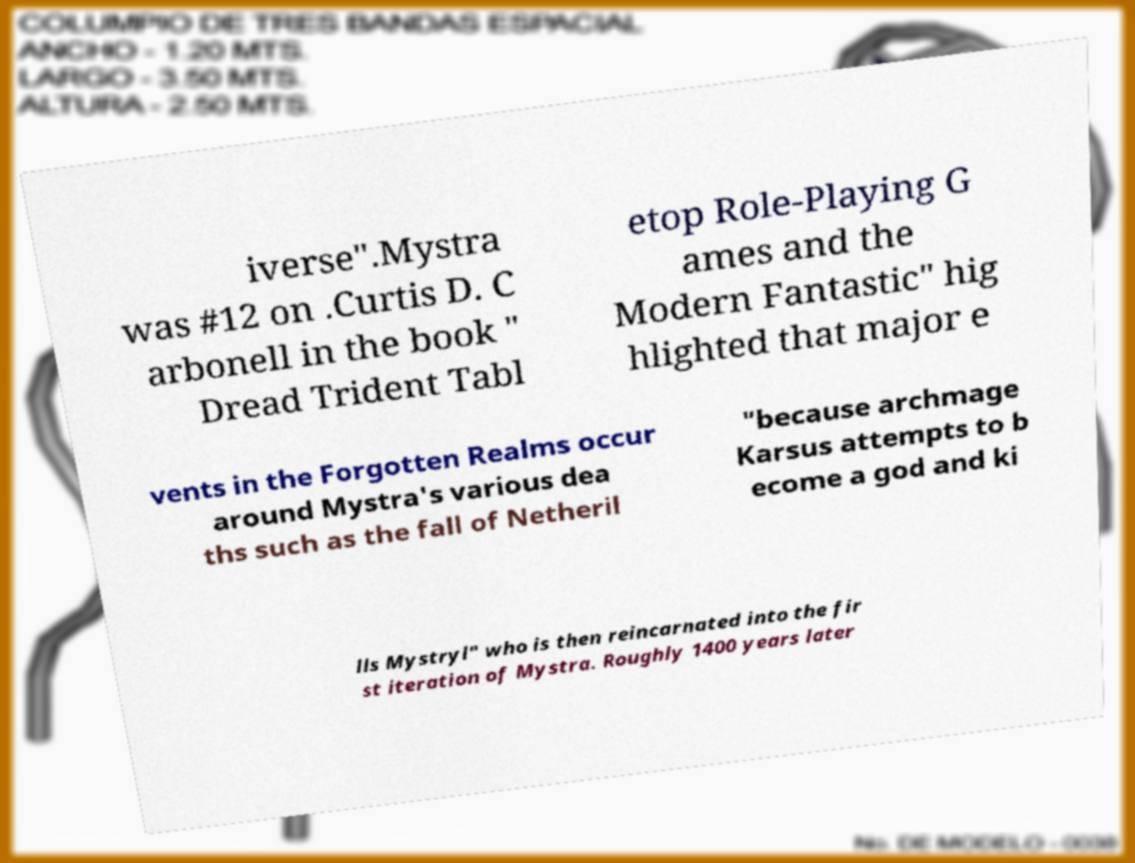Please read and relay the text visible in this image. What does it say? iverse".Mystra was #12 on .Curtis D. C arbonell in the book " Dread Trident Tabl etop Role-Playing G ames and the Modern Fantastic" hig hlighted that major e vents in the Forgotten Realms occur around Mystra's various dea ths such as the fall of Netheril "because archmage Karsus attempts to b ecome a god and ki lls Mystryl" who is then reincarnated into the fir st iteration of Mystra. Roughly 1400 years later 